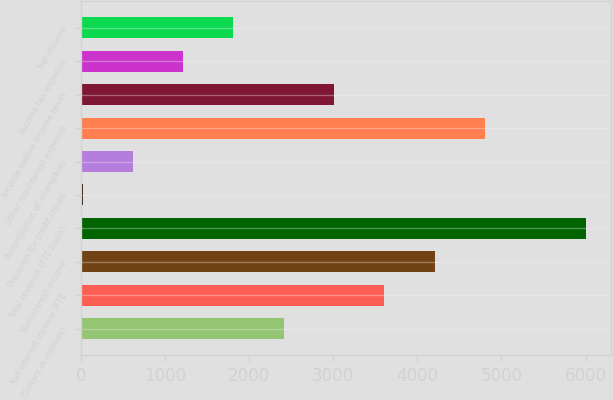Convert chart to OTSL. <chart><loc_0><loc_0><loc_500><loc_500><bar_chart><fcel>(Dollars in millions)<fcel>Net interest income (FTE<fcel>Noninterest income<fcel>Total revenue (FTE basis)<fcel>Provision for credit losses<fcel>Amortization of intangibles<fcel>Other noninterest expense<fcel>Income before income taxes<fcel>Income tax expense<fcel>Net income<nl><fcel>2413.2<fcel>3608.8<fcel>4206.6<fcel>6000<fcel>22<fcel>619.8<fcel>4804.4<fcel>3011<fcel>1217.6<fcel>1815.4<nl></chart> 